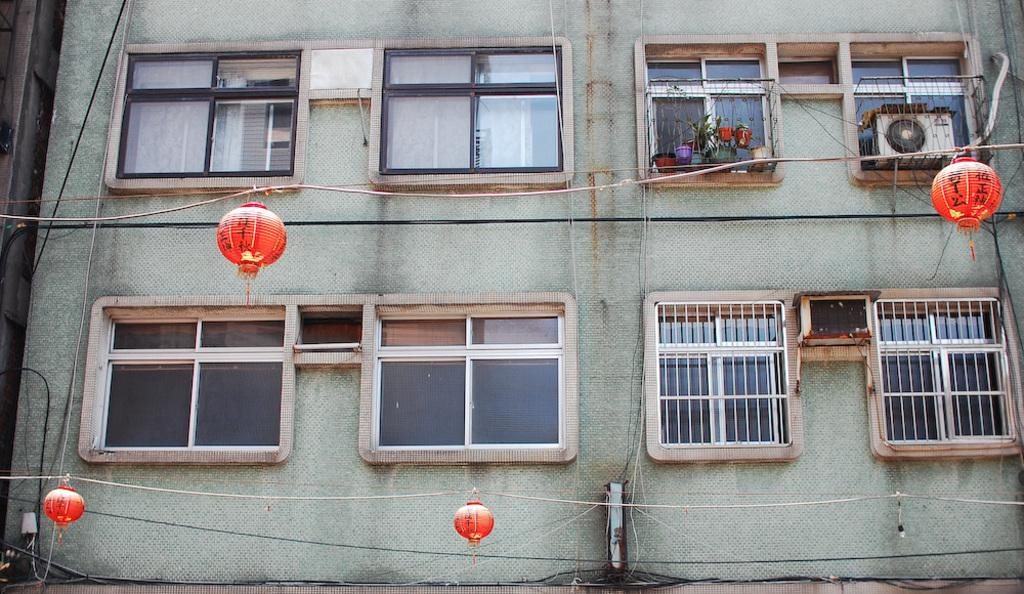What type of structure is visible in the image? There is a building in the image. What feature can be observed on the building? The building has glass windows. What objects are present in the image related to plants? There are flower pots and plants in the image. What device is visible in the image for cooling? There is an air conditioner in the image. What type of lighting is present in the image? There are lights in the image. What items in the image are related to ropes and wires? There are ropes and wires in the image. What can be seen on the left side of the image? There is another building on the left side of the image. Can you see any gravestones or tombstones in the image? There is no cemetery or any gravestones or tombstones present in the image. What type of bait is being used to catch fish in the image? There is no fishing or bait present in the image. What celestial body can be seen shining brightly in the image? There is no star visible in the image. 